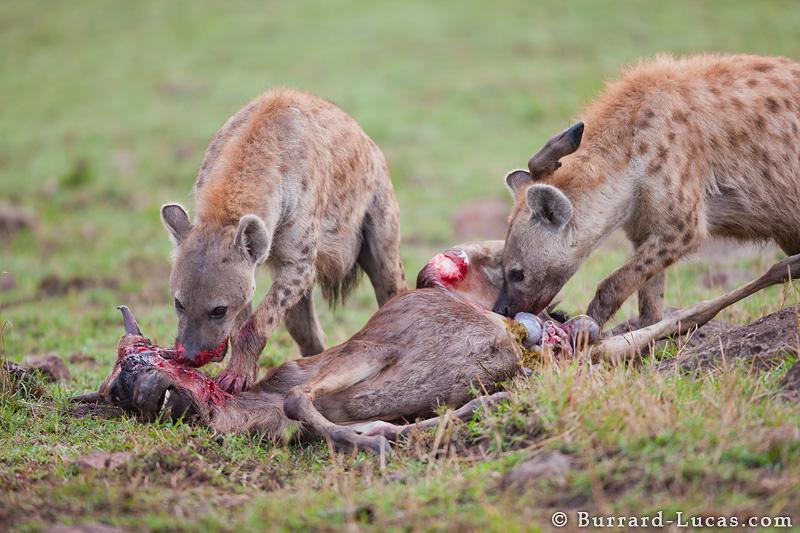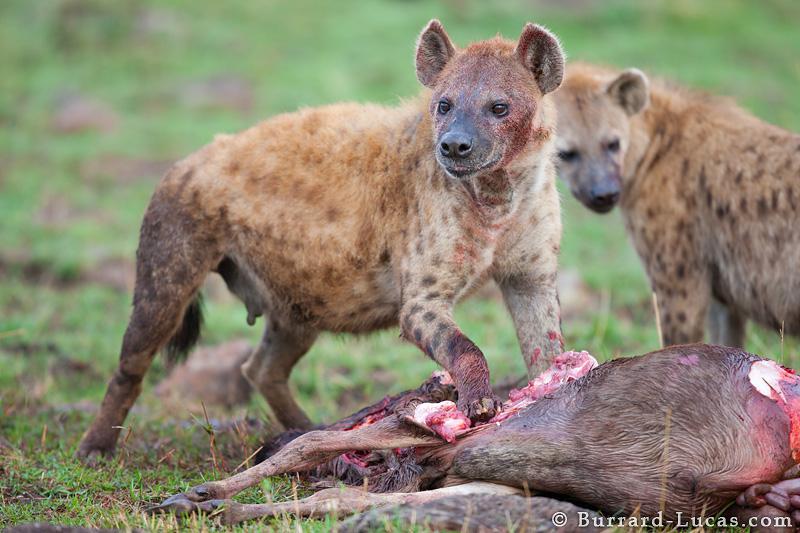The first image is the image on the left, the second image is the image on the right. Analyze the images presented: Is the assertion "In the left image there are two hyenas feeding on a dead animal." valid? Answer yes or no. Yes. The first image is the image on the left, the second image is the image on the right. For the images shown, is this caption "Both images in the pair show two or more hyenas feasting a recent kill." true? Answer yes or no. Yes. 